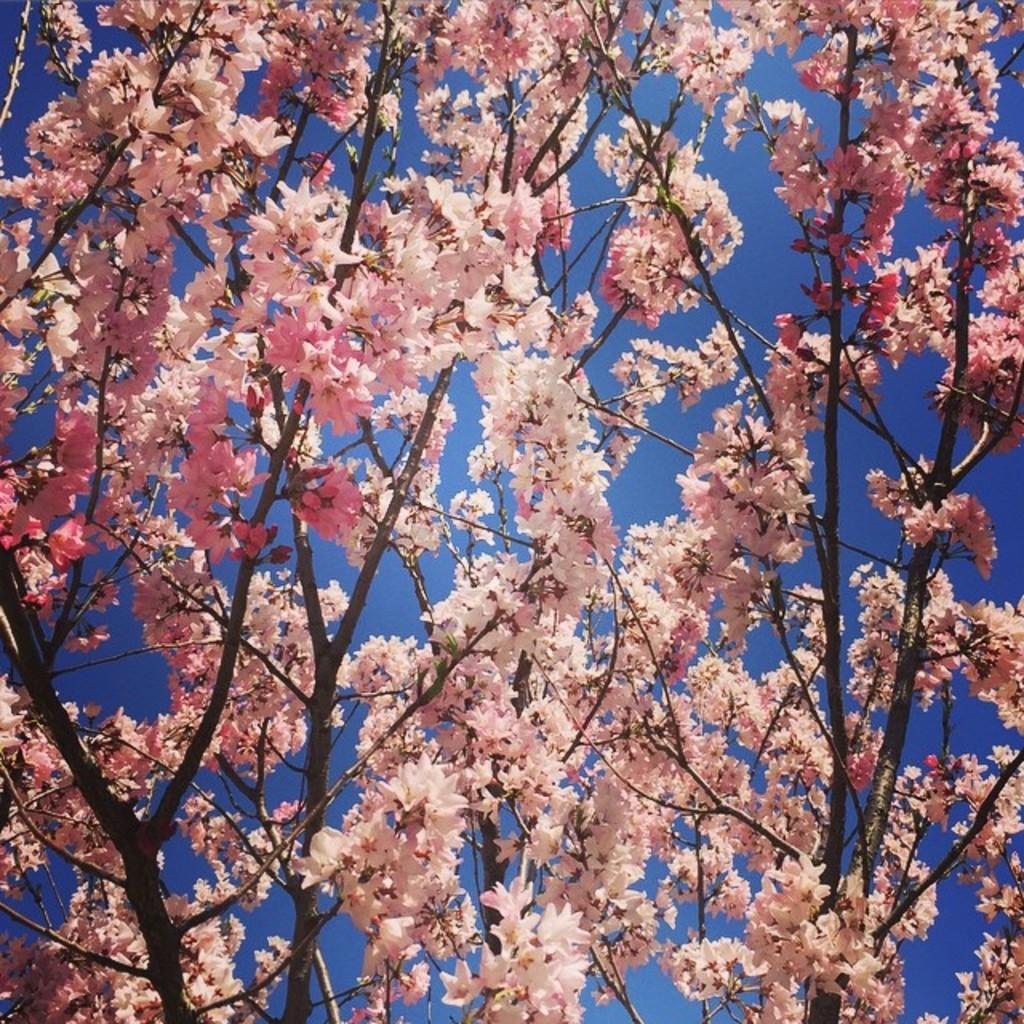What is the main subject of the image? The main subject of the image is a part of a tree. What can be seen on the tree in the image? There are many flowers on the stems in the image. What is visible in the background of the image? The sky is visible in the background of the image. What is the color of the sky in the image? The color of the sky is blue. Is the farmer in the image answering questions about the tree? There is no farmer present in the image, and no one is answering questions about the tree. What is located in the middle of the tree in the image? The image only shows a part of the tree, so it is not possible to determine what is located in the middle of the tree. 